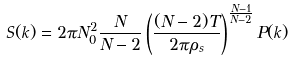<formula> <loc_0><loc_0><loc_500><loc_500>S ( k ) = 2 \pi N ^ { 2 } _ { 0 } \frac { N } { N - 2 } \left ( \frac { ( N - 2 ) T } { 2 \pi \rho _ { s } } \right ) ^ { \frac { N - 1 } { N - 2 } } P ( k )</formula> 